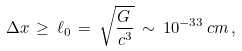Convert formula to latex. <formula><loc_0><loc_0><loc_500><loc_500>\Delta x \, \geq \, \ell _ { 0 } \, = \, \sqrt { \frac { G \, } { c ^ { 3 } } } \, \sim \, 1 0 ^ { - 3 3 } \, c m \, ,</formula> 